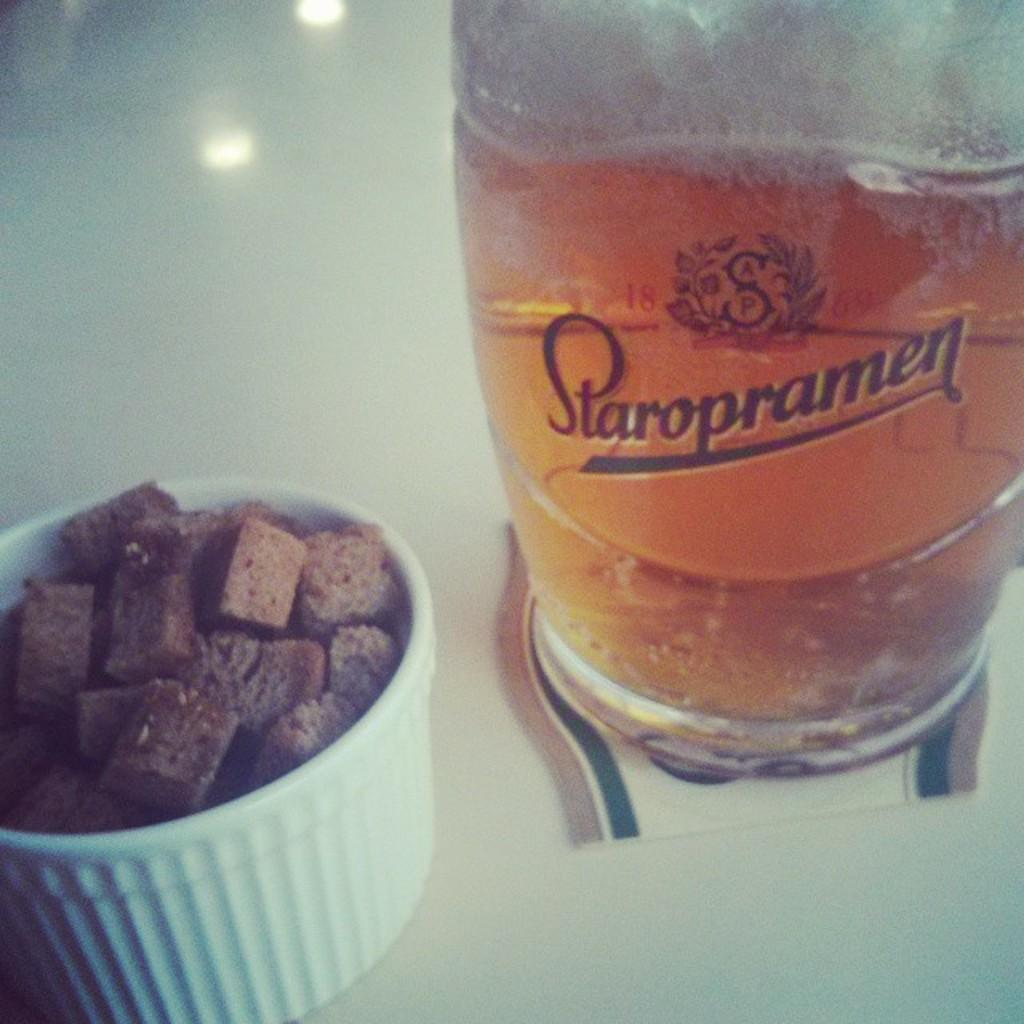What is in the glass that is visible on the right side of the image? There is a glass of wine in the image. Where is the glass of wine located in the image? The glass of wine is on the right side of the image. What type of container holds the chocolates in the image? The chocolates are in a plastic bowl. Where is the plastic bowl with chocolates located in the image? The plastic bowl with chocolates is on the bottom left side of the image. What type of skin is visible on the chocolates in the image? There is no skin visible in the image; it features a glass of wine and a plastic bowl with chocolates. 